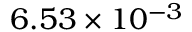<formula> <loc_0><loc_0><loc_500><loc_500>6 . 5 3 \times 1 0 ^ { - 3 }</formula> 